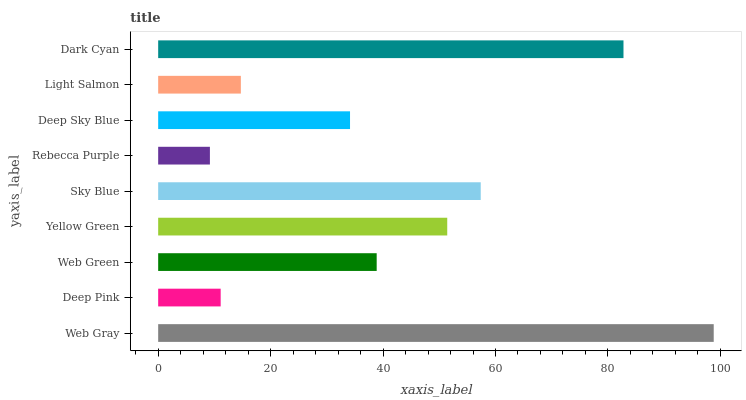Is Rebecca Purple the minimum?
Answer yes or no. Yes. Is Web Gray the maximum?
Answer yes or no. Yes. Is Deep Pink the minimum?
Answer yes or no. No. Is Deep Pink the maximum?
Answer yes or no. No. Is Web Gray greater than Deep Pink?
Answer yes or no. Yes. Is Deep Pink less than Web Gray?
Answer yes or no. Yes. Is Deep Pink greater than Web Gray?
Answer yes or no. No. Is Web Gray less than Deep Pink?
Answer yes or no. No. Is Web Green the high median?
Answer yes or no. Yes. Is Web Green the low median?
Answer yes or no. Yes. Is Yellow Green the high median?
Answer yes or no. No. Is Web Gray the low median?
Answer yes or no. No. 